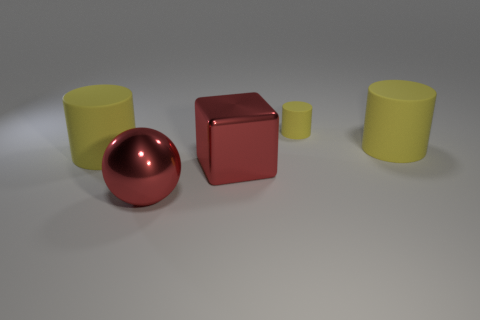There is a large rubber object that is on the right side of the big red sphere; is it the same shape as the tiny thing?
Make the answer very short. Yes. There is a big matte cylinder that is to the left of the large yellow cylinder behind the yellow matte thing to the left of the big red ball; what is its color?
Give a very brief answer. Yellow. Are there any red objects?
Provide a succinct answer. Yes. How many other objects are the same size as the red cube?
Offer a very short reply. 3. Does the big metal ball have the same color as the cube in front of the small yellow thing?
Provide a short and direct response. Yes. What number of things are either big yellow rubber things or red objects?
Provide a short and direct response. 4. Are there any other things that have the same color as the small rubber cylinder?
Your response must be concise. Yes. Is the material of the small yellow cylinder the same as the big yellow thing left of the small matte object?
Make the answer very short. Yes. What is the shape of the thing in front of the big red metallic object right of the red sphere?
Ensure brevity in your answer.  Sphere. What is the shape of the large object that is both behind the large sphere and on the left side of the red metallic cube?
Your answer should be compact. Cylinder. 